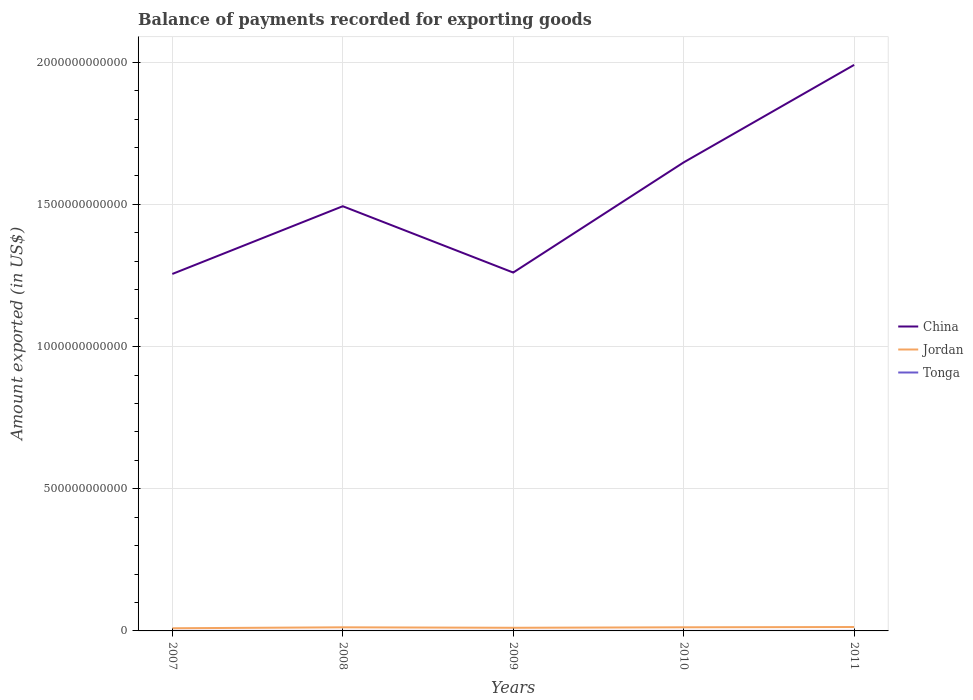Across all years, what is the maximum amount exported in China?
Ensure brevity in your answer.  1.26e+12. What is the total amount exported in China in the graph?
Ensure brevity in your answer.  -3.92e+11. What is the difference between the highest and the second highest amount exported in Jordan?
Keep it short and to the point. 4.36e+09. Is the amount exported in Jordan strictly greater than the amount exported in China over the years?
Offer a very short reply. Yes. How many lines are there?
Provide a short and direct response. 3. How many years are there in the graph?
Ensure brevity in your answer.  5. What is the difference between two consecutive major ticks on the Y-axis?
Make the answer very short. 5.00e+11. Are the values on the major ticks of Y-axis written in scientific E-notation?
Your response must be concise. No. Does the graph contain any zero values?
Provide a short and direct response. No. Does the graph contain grids?
Offer a terse response. Yes. Where does the legend appear in the graph?
Your answer should be very brief. Center right. What is the title of the graph?
Your answer should be very brief. Balance of payments recorded for exporting goods. What is the label or title of the Y-axis?
Provide a short and direct response. Amount exported (in US$). What is the Amount exported (in US$) in China in 2007?
Provide a succinct answer. 1.26e+12. What is the Amount exported (in US$) of Jordan in 2007?
Offer a very short reply. 9.39e+09. What is the Amount exported (in US$) in Tonga in 2007?
Your response must be concise. 4.34e+07. What is the Amount exported (in US$) in China in 2008?
Provide a succinct answer. 1.49e+12. What is the Amount exported (in US$) of Jordan in 2008?
Your response must be concise. 1.27e+1. What is the Amount exported (in US$) of Tonga in 2008?
Offer a terse response. 4.93e+07. What is the Amount exported (in US$) of China in 2009?
Your response must be concise. 1.26e+12. What is the Amount exported (in US$) of Jordan in 2009?
Your response must be concise. 1.11e+1. What is the Amount exported (in US$) in Tonga in 2009?
Provide a succinct answer. 4.35e+07. What is the Amount exported (in US$) in China in 2010?
Keep it short and to the point. 1.65e+12. What is the Amount exported (in US$) in Jordan in 2010?
Provide a succinct answer. 1.28e+1. What is the Amount exported (in US$) in Tonga in 2010?
Your response must be concise. 5.90e+07. What is the Amount exported (in US$) of China in 2011?
Make the answer very short. 1.99e+12. What is the Amount exported (in US$) in Jordan in 2011?
Your answer should be very brief. 1.37e+1. What is the Amount exported (in US$) of Tonga in 2011?
Give a very brief answer. 8.12e+07. Across all years, what is the maximum Amount exported (in US$) of China?
Keep it short and to the point. 1.99e+12. Across all years, what is the maximum Amount exported (in US$) of Jordan?
Make the answer very short. 1.37e+1. Across all years, what is the maximum Amount exported (in US$) in Tonga?
Provide a succinct answer. 8.12e+07. Across all years, what is the minimum Amount exported (in US$) of China?
Your response must be concise. 1.26e+12. Across all years, what is the minimum Amount exported (in US$) in Jordan?
Offer a terse response. 9.39e+09. Across all years, what is the minimum Amount exported (in US$) in Tonga?
Offer a terse response. 4.34e+07. What is the total Amount exported (in US$) of China in the graph?
Offer a very short reply. 7.65e+12. What is the total Amount exported (in US$) of Jordan in the graph?
Offer a terse response. 5.96e+1. What is the total Amount exported (in US$) of Tonga in the graph?
Your answer should be compact. 2.76e+08. What is the difference between the Amount exported (in US$) of China in 2007 and that in 2008?
Offer a very short reply. -2.38e+11. What is the difference between the Amount exported (in US$) in Jordan in 2007 and that in 2008?
Make the answer very short. -3.31e+09. What is the difference between the Amount exported (in US$) of Tonga in 2007 and that in 2008?
Provide a short and direct response. -5.97e+06. What is the difference between the Amount exported (in US$) in China in 2007 and that in 2009?
Keep it short and to the point. -4.97e+09. What is the difference between the Amount exported (in US$) in Jordan in 2007 and that in 2009?
Offer a terse response. -1.67e+09. What is the difference between the Amount exported (in US$) of Tonga in 2007 and that in 2009?
Offer a terse response. -1.01e+05. What is the difference between the Amount exported (in US$) in China in 2007 and that in 2010?
Ensure brevity in your answer.  -3.92e+11. What is the difference between the Amount exported (in US$) of Jordan in 2007 and that in 2010?
Your response must be concise. -3.36e+09. What is the difference between the Amount exported (in US$) in Tonga in 2007 and that in 2010?
Your response must be concise. -1.56e+07. What is the difference between the Amount exported (in US$) of China in 2007 and that in 2011?
Offer a very short reply. -7.35e+11. What is the difference between the Amount exported (in US$) of Jordan in 2007 and that in 2011?
Offer a terse response. -4.36e+09. What is the difference between the Amount exported (in US$) in Tonga in 2007 and that in 2011?
Offer a very short reply. -3.78e+07. What is the difference between the Amount exported (in US$) in China in 2008 and that in 2009?
Your response must be concise. 2.33e+11. What is the difference between the Amount exported (in US$) of Jordan in 2008 and that in 2009?
Offer a very short reply. 1.64e+09. What is the difference between the Amount exported (in US$) in Tonga in 2008 and that in 2009?
Make the answer very short. 5.87e+06. What is the difference between the Amount exported (in US$) in China in 2008 and that in 2010?
Offer a terse response. -1.54e+11. What is the difference between the Amount exported (in US$) in Jordan in 2008 and that in 2010?
Your response must be concise. -5.28e+07. What is the difference between the Amount exported (in US$) in Tonga in 2008 and that in 2010?
Provide a short and direct response. -9.67e+06. What is the difference between the Amount exported (in US$) of China in 2008 and that in 2011?
Offer a very short reply. -4.97e+11. What is the difference between the Amount exported (in US$) of Jordan in 2008 and that in 2011?
Ensure brevity in your answer.  -1.04e+09. What is the difference between the Amount exported (in US$) of Tonga in 2008 and that in 2011?
Your response must be concise. -3.18e+07. What is the difference between the Amount exported (in US$) of China in 2009 and that in 2010?
Provide a succinct answer. -3.87e+11. What is the difference between the Amount exported (in US$) in Jordan in 2009 and that in 2010?
Make the answer very short. -1.69e+09. What is the difference between the Amount exported (in US$) of Tonga in 2009 and that in 2010?
Give a very brief answer. -1.55e+07. What is the difference between the Amount exported (in US$) of China in 2009 and that in 2011?
Keep it short and to the point. -7.30e+11. What is the difference between the Amount exported (in US$) of Jordan in 2009 and that in 2011?
Your response must be concise. -2.68e+09. What is the difference between the Amount exported (in US$) in Tonga in 2009 and that in 2011?
Offer a terse response. -3.77e+07. What is the difference between the Amount exported (in US$) in China in 2010 and that in 2011?
Offer a terse response. -3.43e+11. What is the difference between the Amount exported (in US$) in Jordan in 2010 and that in 2011?
Your answer should be very brief. -9.92e+08. What is the difference between the Amount exported (in US$) of Tonga in 2010 and that in 2011?
Your answer should be compact. -2.22e+07. What is the difference between the Amount exported (in US$) in China in 2007 and the Amount exported (in US$) in Jordan in 2008?
Your answer should be very brief. 1.24e+12. What is the difference between the Amount exported (in US$) of China in 2007 and the Amount exported (in US$) of Tonga in 2008?
Your answer should be very brief. 1.26e+12. What is the difference between the Amount exported (in US$) of Jordan in 2007 and the Amount exported (in US$) of Tonga in 2008?
Give a very brief answer. 9.34e+09. What is the difference between the Amount exported (in US$) of China in 2007 and the Amount exported (in US$) of Jordan in 2009?
Your answer should be compact. 1.24e+12. What is the difference between the Amount exported (in US$) in China in 2007 and the Amount exported (in US$) in Tonga in 2009?
Offer a very short reply. 1.26e+12. What is the difference between the Amount exported (in US$) in Jordan in 2007 and the Amount exported (in US$) in Tonga in 2009?
Offer a terse response. 9.34e+09. What is the difference between the Amount exported (in US$) of China in 2007 and the Amount exported (in US$) of Jordan in 2010?
Ensure brevity in your answer.  1.24e+12. What is the difference between the Amount exported (in US$) in China in 2007 and the Amount exported (in US$) in Tonga in 2010?
Your answer should be compact. 1.26e+12. What is the difference between the Amount exported (in US$) in Jordan in 2007 and the Amount exported (in US$) in Tonga in 2010?
Make the answer very short. 9.33e+09. What is the difference between the Amount exported (in US$) in China in 2007 and the Amount exported (in US$) in Jordan in 2011?
Make the answer very short. 1.24e+12. What is the difference between the Amount exported (in US$) of China in 2007 and the Amount exported (in US$) of Tonga in 2011?
Provide a succinct answer. 1.26e+12. What is the difference between the Amount exported (in US$) of Jordan in 2007 and the Amount exported (in US$) of Tonga in 2011?
Provide a succinct answer. 9.31e+09. What is the difference between the Amount exported (in US$) of China in 2008 and the Amount exported (in US$) of Jordan in 2009?
Your answer should be very brief. 1.48e+12. What is the difference between the Amount exported (in US$) of China in 2008 and the Amount exported (in US$) of Tonga in 2009?
Ensure brevity in your answer.  1.49e+12. What is the difference between the Amount exported (in US$) in Jordan in 2008 and the Amount exported (in US$) in Tonga in 2009?
Your response must be concise. 1.27e+1. What is the difference between the Amount exported (in US$) in China in 2008 and the Amount exported (in US$) in Jordan in 2010?
Keep it short and to the point. 1.48e+12. What is the difference between the Amount exported (in US$) of China in 2008 and the Amount exported (in US$) of Tonga in 2010?
Give a very brief answer. 1.49e+12. What is the difference between the Amount exported (in US$) of Jordan in 2008 and the Amount exported (in US$) of Tonga in 2010?
Ensure brevity in your answer.  1.26e+1. What is the difference between the Amount exported (in US$) in China in 2008 and the Amount exported (in US$) in Jordan in 2011?
Your response must be concise. 1.48e+12. What is the difference between the Amount exported (in US$) of China in 2008 and the Amount exported (in US$) of Tonga in 2011?
Offer a very short reply. 1.49e+12. What is the difference between the Amount exported (in US$) of Jordan in 2008 and the Amount exported (in US$) of Tonga in 2011?
Provide a short and direct response. 1.26e+1. What is the difference between the Amount exported (in US$) in China in 2009 and the Amount exported (in US$) in Jordan in 2010?
Provide a short and direct response. 1.25e+12. What is the difference between the Amount exported (in US$) in China in 2009 and the Amount exported (in US$) in Tonga in 2010?
Give a very brief answer. 1.26e+12. What is the difference between the Amount exported (in US$) in Jordan in 2009 and the Amount exported (in US$) in Tonga in 2010?
Offer a terse response. 1.10e+1. What is the difference between the Amount exported (in US$) of China in 2009 and the Amount exported (in US$) of Jordan in 2011?
Offer a very short reply. 1.25e+12. What is the difference between the Amount exported (in US$) in China in 2009 and the Amount exported (in US$) in Tonga in 2011?
Offer a terse response. 1.26e+12. What is the difference between the Amount exported (in US$) of Jordan in 2009 and the Amount exported (in US$) of Tonga in 2011?
Keep it short and to the point. 1.10e+1. What is the difference between the Amount exported (in US$) in China in 2010 and the Amount exported (in US$) in Jordan in 2011?
Offer a very short reply. 1.63e+12. What is the difference between the Amount exported (in US$) in China in 2010 and the Amount exported (in US$) in Tonga in 2011?
Ensure brevity in your answer.  1.65e+12. What is the difference between the Amount exported (in US$) of Jordan in 2010 and the Amount exported (in US$) of Tonga in 2011?
Ensure brevity in your answer.  1.27e+1. What is the average Amount exported (in US$) in China per year?
Provide a short and direct response. 1.53e+12. What is the average Amount exported (in US$) of Jordan per year?
Your answer should be compact. 1.19e+1. What is the average Amount exported (in US$) in Tonga per year?
Offer a very short reply. 5.53e+07. In the year 2007, what is the difference between the Amount exported (in US$) in China and Amount exported (in US$) in Jordan?
Provide a succinct answer. 1.25e+12. In the year 2007, what is the difference between the Amount exported (in US$) of China and Amount exported (in US$) of Tonga?
Your answer should be very brief. 1.26e+12. In the year 2007, what is the difference between the Amount exported (in US$) of Jordan and Amount exported (in US$) of Tonga?
Your answer should be very brief. 9.34e+09. In the year 2008, what is the difference between the Amount exported (in US$) in China and Amount exported (in US$) in Jordan?
Your answer should be compact. 1.48e+12. In the year 2008, what is the difference between the Amount exported (in US$) in China and Amount exported (in US$) in Tonga?
Offer a terse response. 1.49e+12. In the year 2008, what is the difference between the Amount exported (in US$) of Jordan and Amount exported (in US$) of Tonga?
Ensure brevity in your answer.  1.26e+1. In the year 2009, what is the difference between the Amount exported (in US$) of China and Amount exported (in US$) of Jordan?
Ensure brevity in your answer.  1.25e+12. In the year 2009, what is the difference between the Amount exported (in US$) in China and Amount exported (in US$) in Tonga?
Provide a succinct answer. 1.26e+12. In the year 2009, what is the difference between the Amount exported (in US$) of Jordan and Amount exported (in US$) of Tonga?
Make the answer very short. 1.10e+1. In the year 2010, what is the difference between the Amount exported (in US$) in China and Amount exported (in US$) in Jordan?
Your answer should be very brief. 1.63e+12. In the year 2010, what is the difference between the Amount exported (in US$) in China and Amount exported (in US$) in Tonga?
Your answer should be very brief. 1.65e+12. In the year 2010, what is the difference between the Amount exported (in US$) in Jordan and Amount exported (in US$) in Tonga?
Your answer should be very brief. 1.27e+1. In the year 2011, what is the difference between the Amount exported (in US$) of China and Amount exported (in US$) of Jordan?
Offer a terse response. 1.98e+12. In the year 2011, what is the difference between the Amount exported (in US$) in China and Amount exported (in US$) in Tonga?
Offer a terse response. 1.99e+12. In the year 2011, what is the difference between the Amount exported (in US$) in Jordan and Amount exported (in US$) in Tonga?
Keep it short and to the point. 1.37e+1. What is the ratio of the Amount exported (in US$) of China in 2007 to that in 2008?
Make the answer very short. 0.84. What is the ratio of the Amount exported (in US$) in Jordan in 2007 to that in 2008?
Ensure brevity in your answer.  0.74. What is the ratio of the Amount exported (in US$) of Tonga in 2007 to that in 2008?
Keep it short and to the point. 0.88. What is the ratio of the Amount exported (in US$) in Jordan in 2007 to that in 2009?
Give a very brief answer. 0.85. What is the ratio of the Amount exported (in US$) in Tonga in 2007 to that in 2009?
Provide a short and direct response. 1. What is the ratio of the Amount exported (in US$) in China in 2007 to that in 2010?
Provide a short and direct response. 0.76. What is the ratio of the Amount exported (in US$) of Jordan in 2007 to that in 2010?
Keep it short and to the point. 0.74. What is the ratio of the Amount exported (in US$) of Tonga in 2007 to that in 2010?
Your response must be concise. 0.73. What is the ratio of the Amount exported (in US$) in China in 2007 to that in 2011?
Provide a short and direct response. 0.63. What is the ratio of the Amount exported (in US$) of Jordan in 2007 to that in 2011?
Offer a terse response. 0.68. What is the ratio of the Amount exported (in US$) in Tonga in 2007 to that in 2011?
Offer a terse response. 0.53. What is the ratio of the Amount exported (in US$) in China in 2008 to that in 2009?
Give a very brief answer. 1.19. What is the ratio of the Amount exported (in US$) in Jordan in 2008 to that in 2009?
Your answer should be very brief. 1.15. What is the ratio of the Amount exported (in US$) of Tonga in 2008 to that in 2009?
Your answer should be very brief. 1.14. What is the ratio of the Amount exported (in US$) in China in 2008 to that in 2010?
Give a very brief answer. 0.91. What is the ratio of the Amount exported (in US$) of Tonga in 2008 to that in 2010?
Give a very brief answer. 0.84. What is the ratio of the Amount exported (in US$) in China in 2008 to that in 2011?
Keep it short and to the point. 0.75. What is the ratio of the Amount exported (in US$) in Jordan in 2008 to that in 2011?
Provide a succinct answer. 0.92. What is the ratio of the Amount exported (in US$) in Tonga in 2008 to that in 2011?
Ensure brevity in your answer.  0.61. What is the ratio of the Amount exported (in US$) of China in 2009 to that in 2010?
Make the answer very short. 0.76. What is the ratio of the Amount exported (in US$) in Jordan in 2009 to that in 2010?
Offer a terse response. 0.87. What is the ratio of the Amount exported (in US$) in Tonga in 2009 to that in 2010?
Offer a very short reply. 0.74. What is the ratio of the Amount exported (in US$) in China in 2009 to that in 2011?
Offer a terse response. 0.63. What is the ratio of the Amount exported (in US$) of Jordan in 2009 to that in 2011?
Give a very brief answer. 0.8. What is the ratio of the Amount exported (in US$) in Tonga in 2009 to that in 2011?
Provide a short and direct response. 0.54. What is the ratio of the Amount exported (in US$) in China in 2010 to that in 2011?
Your answer should be compact. 0.83. What is the ratio of the Amount exported (in US$) of Jordan in 2010 to that in 2011?
Your answer should be compact. 0.93. What is the ratio of the Amount exported (in US$) in Tonga in 2010 to that in 2011?
Make the answer very short. 0.73. What is the difference between the highest and the second highest Amount exported (in US$) in China?
Give a very brief answer. 3.43e+11. What is the difference between the highest and the second highest Amount exported (in US$) of Jordan?
Make the answer very short. 9.92e+08. What is the difference between the highest and the second highest Amount exported (in US$) of Tonga?
Your response must be concise. 2.22e+07. What is the difference between the highest and the lowest Amount exported (in US$) of China?
Your answer should be very brief. 7.35e+11. What is the difference between the highest and the lowest Amount exported (in US$) of Jordan?
Provide a succinct answer. 4.36e+09. What is the difference between the highest and the lowest Amount exported (in US$) in Tonga?
Your answer should be compact. 3.78e+07. 